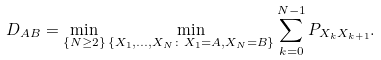<formula> <loc_0><loc_0><loc_500><loc_500>D _ { A B } = \min _ { \{ N \geq 2 \} } \min _ { \{ X _ { 1 } , \dots , X _ { N } \colon X _ { 1 } = A , X _ { N } = B \} } \sum _ { k = 0 } ^ { N - 1 } P _ { X _ { k } X _ { k + 1 } } .</formula> 